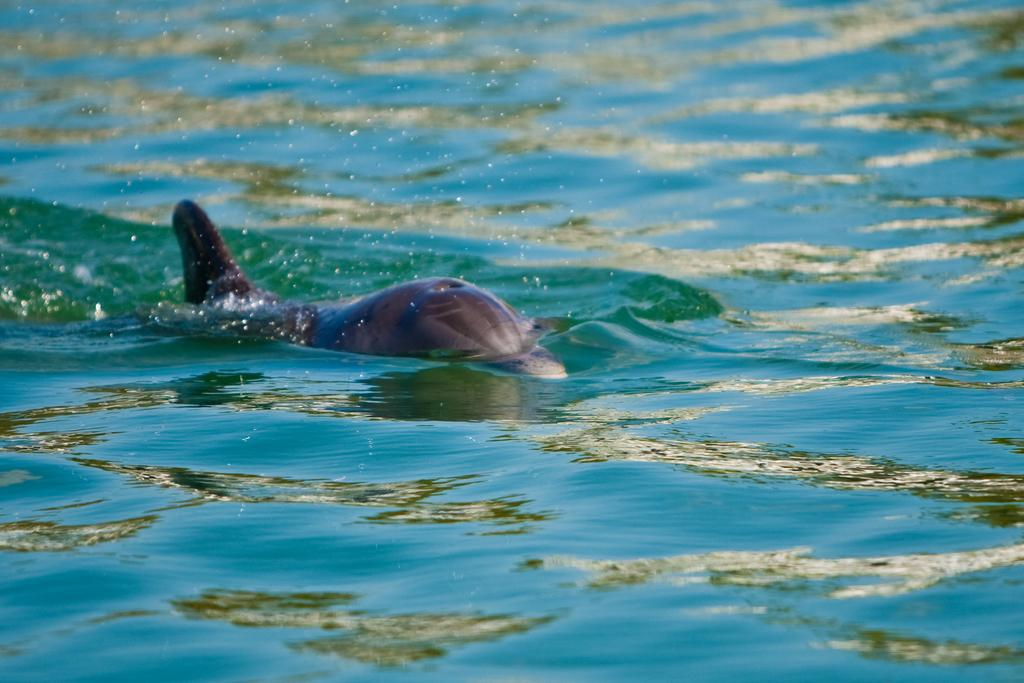What is the main subject of the image? There is a big fish in the image. Where is the fish located? The fish is on the water. What type of shop can be seen in the background of the image? There is no shop present in the image; it only features a big fish on the water. Can you tell me how many crackers are floating near the fish? There are no crackers present in the image; it only features a big fish on the water. 